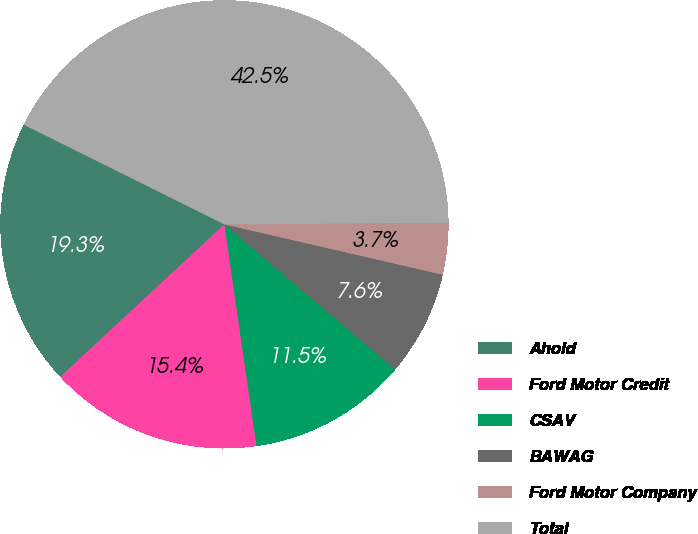Convert chart. <chart><loc_0><loc_0><loc_500><loc_500><pie_chart><fcel>Ahold<fcel>Ford Motor Credit<fcel>CSAV<fcel>BAWAG<fcel>Ford Motor Company<fcel>Total<nl><fcel>19.25%<fcel>15.37%<fcel>11.49%<fcel>7.61%<fcel>3.73%<fcel>42.53%<nl></chart> 